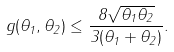<formula> <loc_0><loc_0><loc_500><loc_500>g ( \theta _ { 1 } , \theta _ { 2 } ) \leq \frac { 8 \sqrt { \theta _ { 1 } \theta _ { 2 } } } { 3 ( \theta _ { 1 } + \theta _ { 2 } ) } .</formula> 